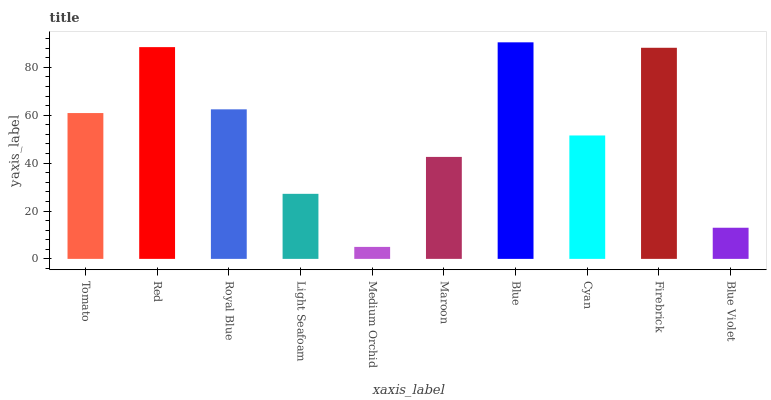Is Red the minimum?
Answer yes or no. No. Is Red the maximum?
Answer yes or no. No. Is Red greater than Tomato?
Answer yes or no. Yes. Is Tomato less than Red?
Answer yes or no. Yes. Is Tomato greater than Red?
Answer yes or no. No. Is Red less than Tomato?
Answer yes or no. No. Is Tomato the high median?
Answer yes or no. Yes. Is Cyan the low median?
Answer yes or no. Yes. Is Red the high median?
Answer yes or no. No. Is Blue the low median?
Answer yes or no. No. 